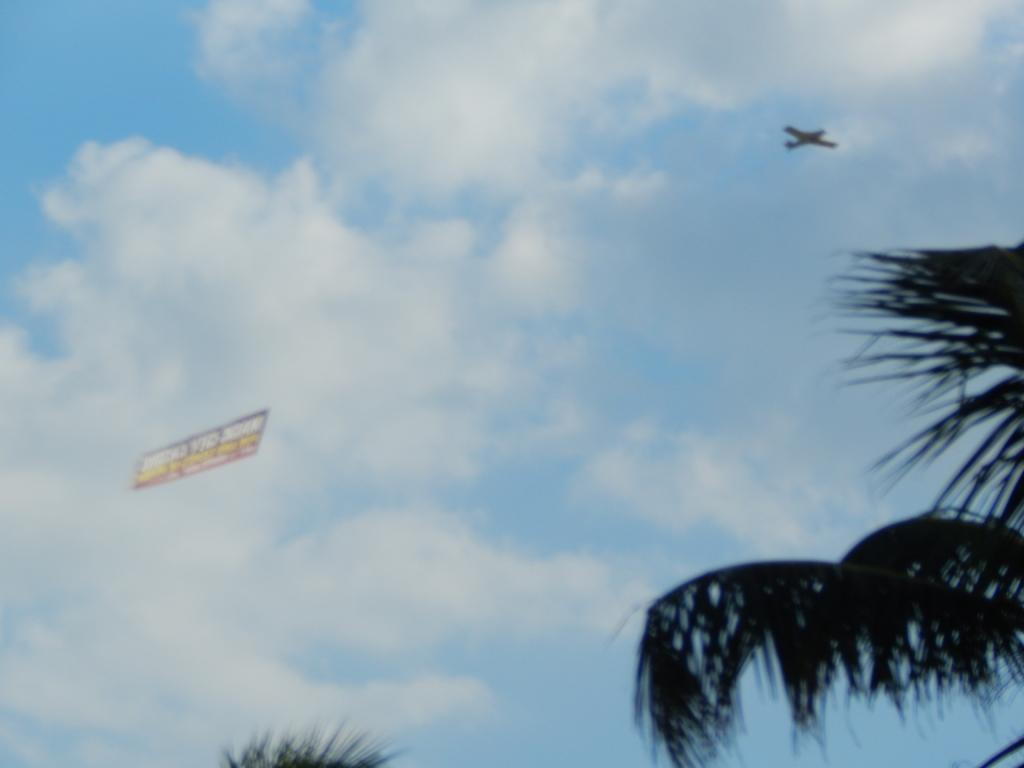What type of natural elements can be seen in the image? There are trees in the image. What man-made object is visible in the image? There is an aircraft in the image. What is hanging in the sky in the image? There is a banner in the sky in the image. How many goats are climbing the trees in the image? There are no goats present in the image, so it is not possible to determine how many might be climbing the trees. What type of writing instrument is being used to create the banner in the image? The image does not provide information about the writing instrument used to create the banner, so it is not possible to determine if a quill was used. 